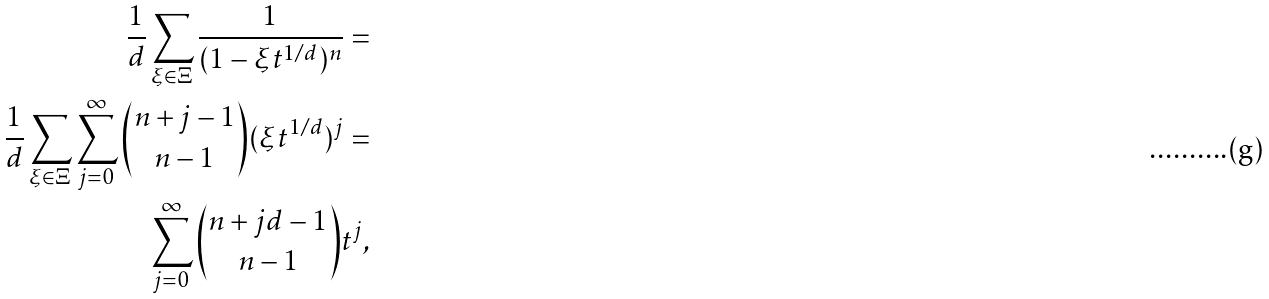Convert formula to latex. <formula><loc_0><loc_0><loc_500><loc_500>\frac { 1 } { d } \sum _ { \xi \in \Xi } \frac { 1 } { ( 1 - \xi t ^ { 1 / d } ) ^ { n } } = \\ \frac { 1 } { d } \sum _ { \xi \in \Xi } \sum _ { j = 0 } ^ { \infty } \binom { n + j - 1 } { n - 1 } ( \xi t ^ { 1 / d } ) ^ { j } = \\ \sum _ { j = 0 } ^ { \infty } \binom { n + j d - 1 } { n - 1 } t ^ { j } ,</formula> 